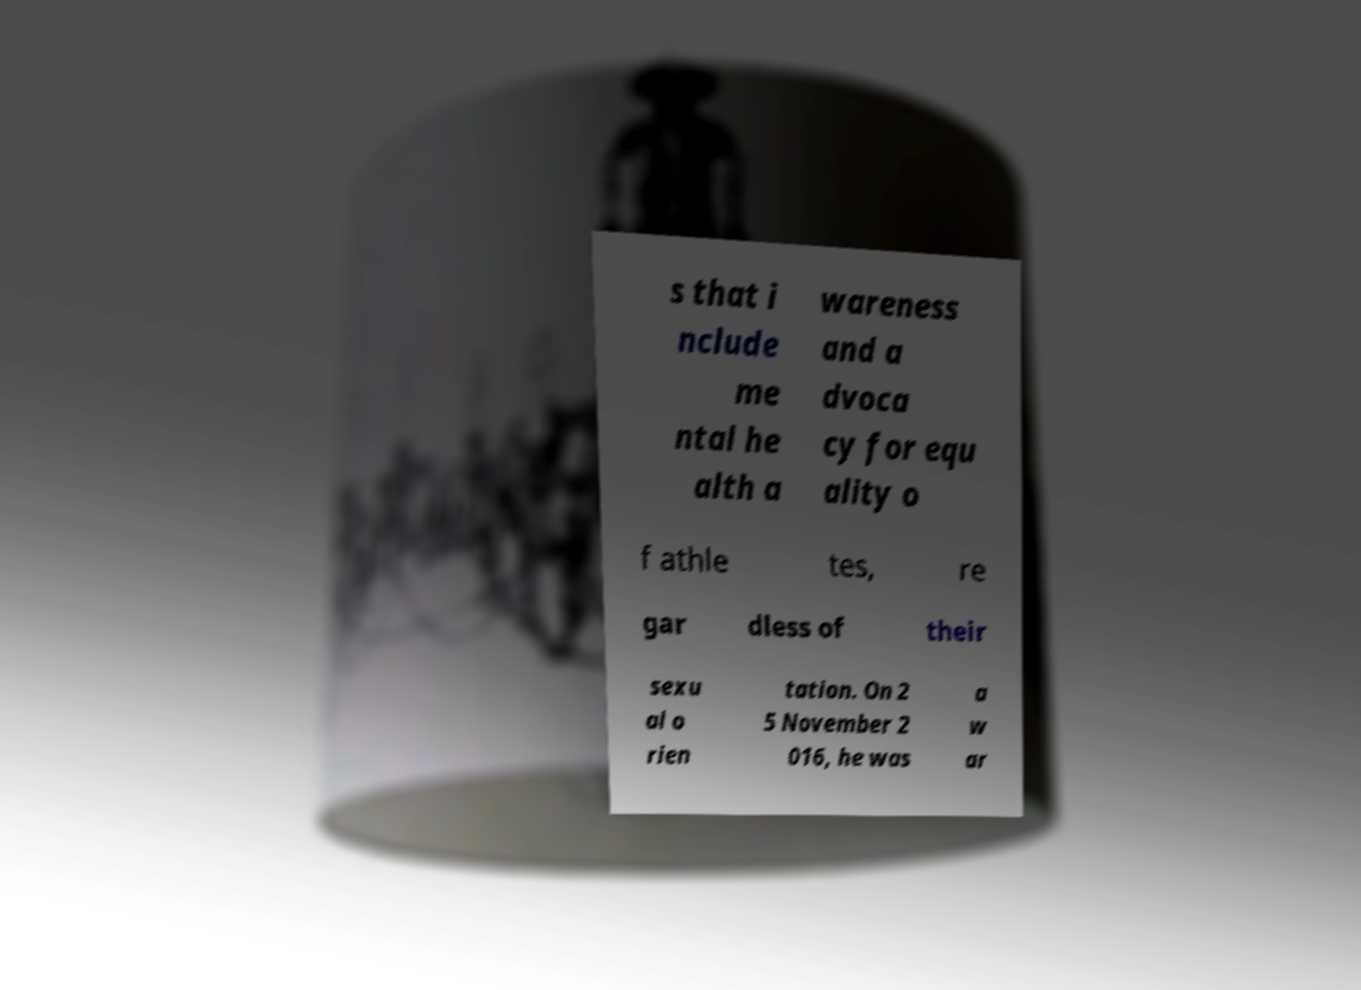Can you read and provide the text displayed in the image?This photo seems to have some interesting text. Can you extract and type it out for me? s that i nclude me ntal he alth a wareness and a dvoca cy for equ ality o f athle tes, re gar dless of their sexu al o rien tation. On 2 5 November 2 016, he was a w ar 